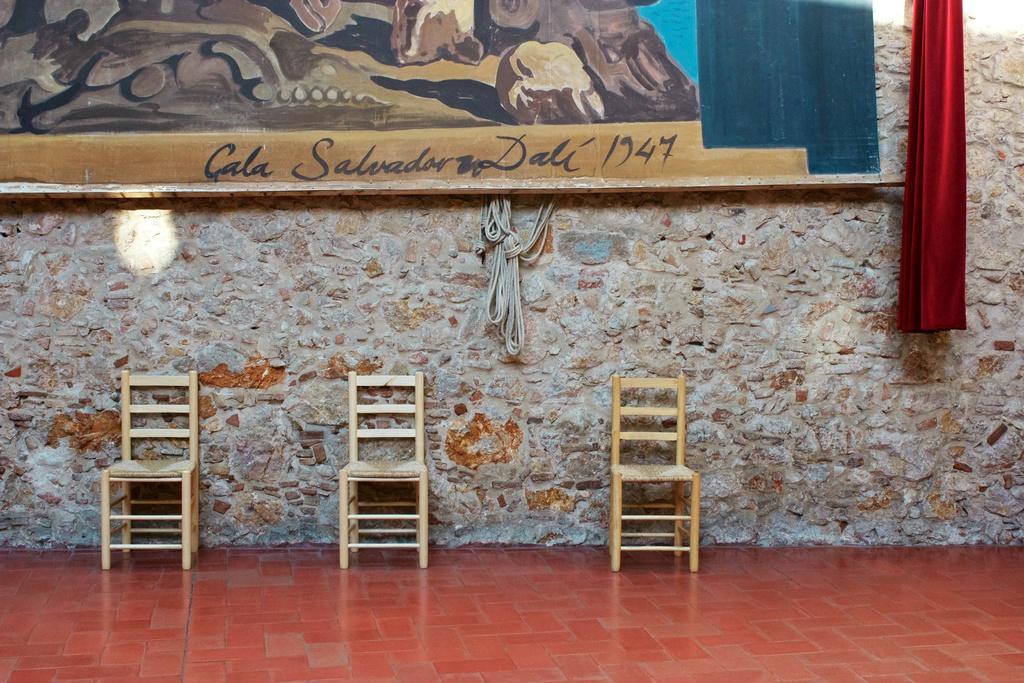What year is mentioned?
Offer a terse response. 1947. 